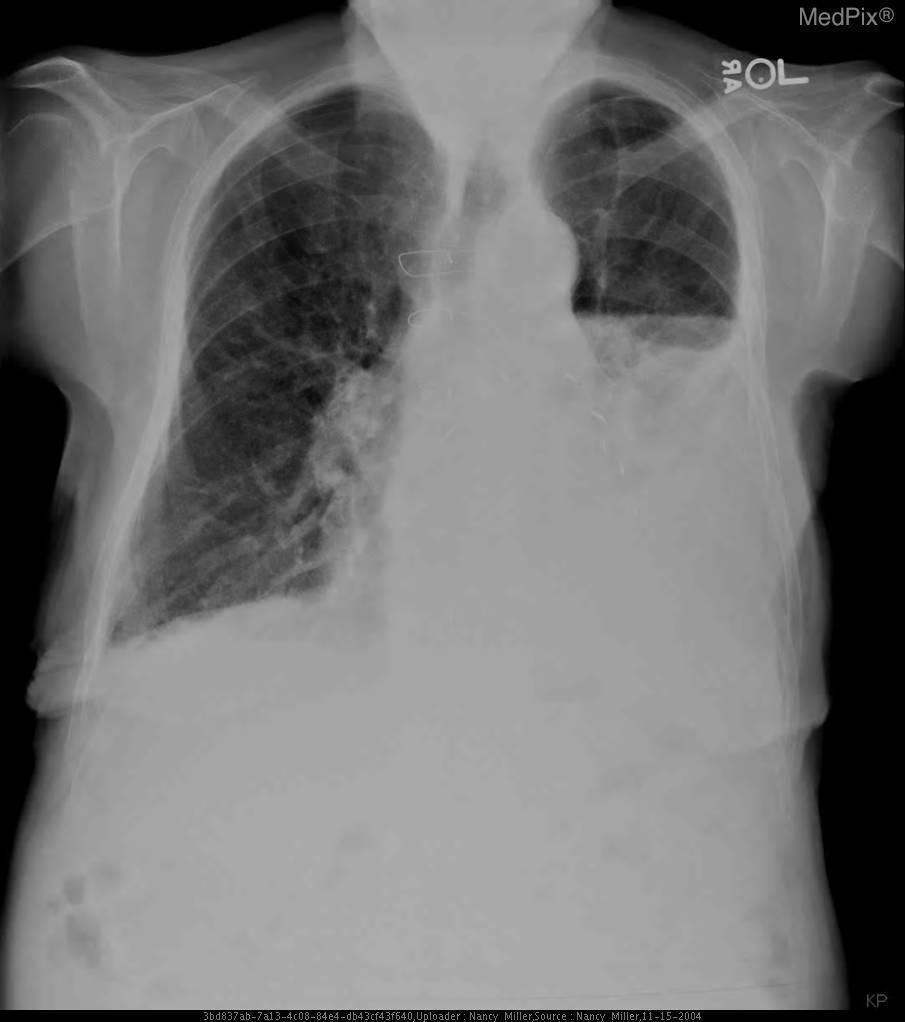What does this represent?
Short answer required. Hydropneumothorax. What kind of image is this?
Short answer required. Chest x ray. What modality is this?
Quick response, please. Chest x ray. Which side is abnormal?
Give a very brief answer. Left. Which lung has a defect?
Keep it brief. Left. Do you see fluid in the left lung?
Concise answer only. Yes. Is there fluid in the left lung?
Answer briefly. Yes. 